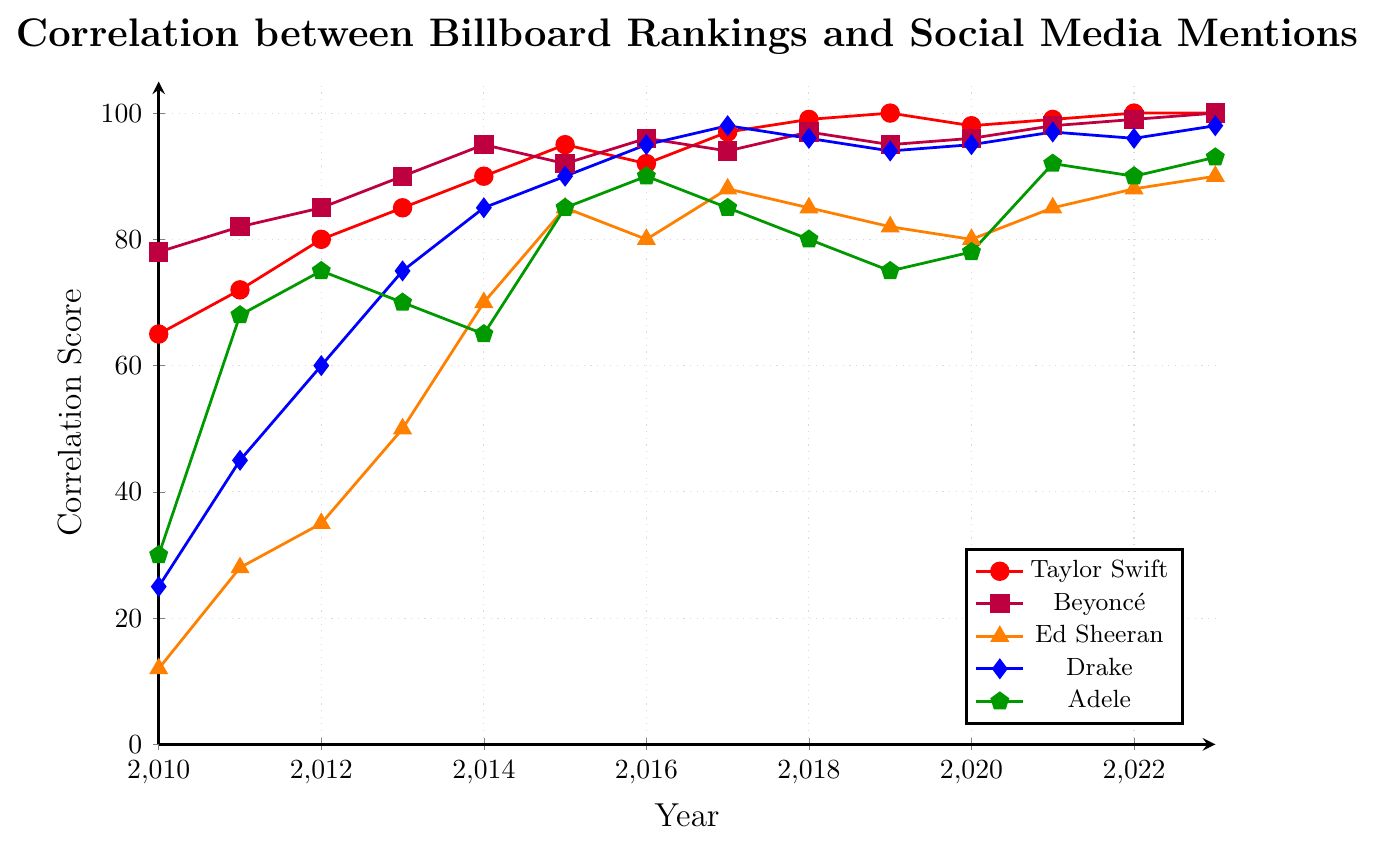When did Taylor Swift's correlation score first reach 100? According to the chart, Taylor Swift's correlation score first reached 100 in the year 2019.
Answer: 2019 Which artist had the highest correlation score in 2023? In 2023, Beyoncé and Taylor Swift both had a correlation score of 100, which is the highest.
Answer: Beyoncé and Taylor Swift How did Adele's correlation score change from 2019 to 2020? Adele's score increased from 75 in 2019 to 78 in 2020, indicating an increase of 3 points.
Answer: Increased by 3 Which artist showed a continuous increase in correlation score from 2010 to 2013? Both Taylor Swift and Beyoncé showed a continuous increase in their correlation scores from 2010 (65 and 78, respectively) to 2013 (85 and 90, respectively).
Answer: Taylor Swift and Beyoncé What is the average correlation score for Ed Sheeran between 2010 and 2015? The average score is calculated by summing Ed Sheeran's scores from 2010 (12), 2011 (28), 2012 (35), 2013 (50), 2014 (70), and 2015 (85) and then dividing by the number of years (6). The sum is 280, and the average is 280 / 6 = 46.67.
Answer: 46.67 Compare the correlation scores of The Weeknd and Billie Eilish in 2023. In 2023, The Weeknd's correlation score was 97, whereas Billie Eilish's score was 94. The Weeknd had a higher score.
Answer: The Weeknd had a higher score Which artist's correlation score had the most significant increase from 2010 to 2023? Comparing the scores from 2010 to 2023 for all artists, Ed Sheeran had the most significant increase from 12 in 2010 to 90 in 2023, an increase of 78 points.
Answer: Ed Sheeran Identify the pattern of Beyoncé's correlation score from 2017 to 2023. Beyoncé's correlation score fluctuated, slightly decreasing in 2019 but otherwise increasing steadily from 94 in 2017 to 100 in 2023.
Answer: Steady increase with a slight decrease in 2019 Which artist had a decrease in correlation score between 2019 and 2020? Taylor Swift's correlation score decreased from 100 in 2019 to 98 in 2020.
Answer: Taylor Swift 